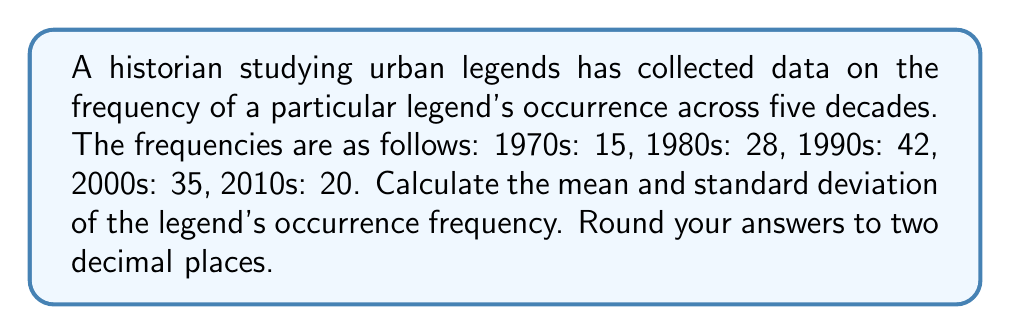Can you solve this math problem? To solve this problem, we'll follow these steps:

1. Calculate the mean (average) of the frequencies.
2. Calculate the variance.
3. Calculate the standard deviation.

Step 1: Calculate the mean
The mean is the sum of all values divided by the number of values.

$\mu = \frac{\sum_{i=1}^{n} x_i}{n}$

Where $x_i$ are the individual frequencies and $n$ is the number of decades.

$\mu = \frac{15 + 28 + 42 + 35 + 20}{5} = \frac{140}{5} = 28$

Step 2: Calculate the variance
The variance is the average of the squared differences from the mean.

$\sigma^2 = \frac{\sum_{i=1}^{n} (x_i - \mu)^2}{n}$

Let's calculate each term:
$(15 - 28)^2 = (-13)^2 = 169$
$(28 - 28)^2 = 0$
$(42 - 28)^2 = 14^2 = 196$
$(35 - 28)^2 = 7^2 = 49$
$(20 - 28)^2 = (-8)^2 = 64$

Sum these up and divide by n:

$\sigma^2 = \frac{169 + 0 + 196 + 49 + 64}{5} = \frac{478}{5} = 95.6$

Step 3: Calculate the standard deviation
The standard deviation is the square root of the variance.

$\sigma = \sqrt{\sigma^2} = \sqrt{95.6} \approx 9.78$

Rounding to two decimal places:
Mean: 28.00
Standard Deviation: 9.78
Answer: Mean: 28.00, Standard Deviation: 9.78 